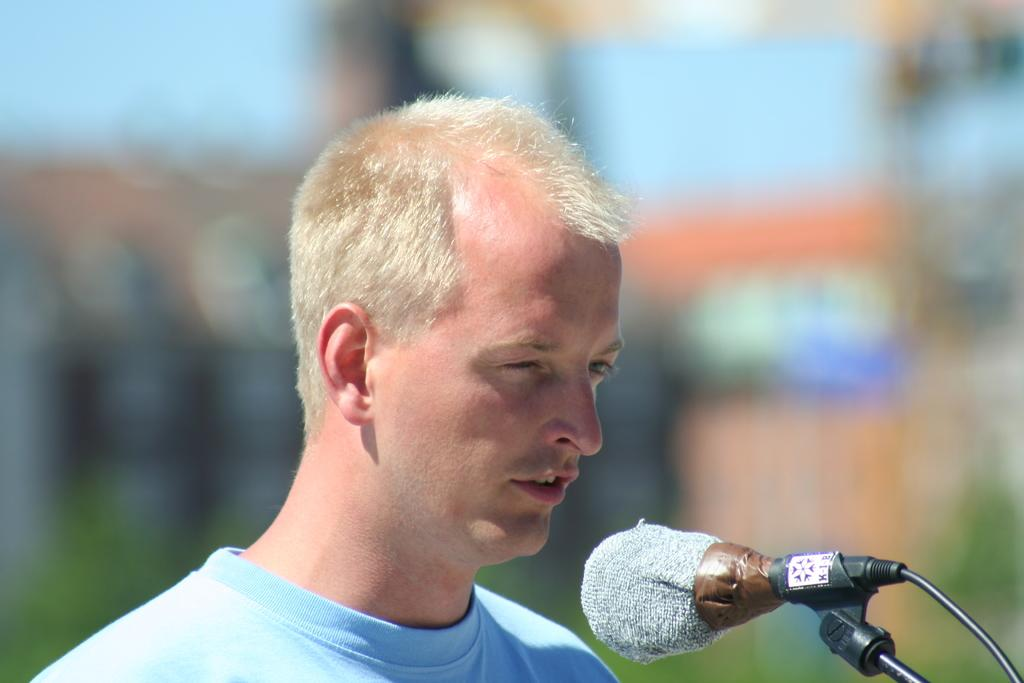Who or what is the main subject of the image? There is a person in the image. What object is in front of the person? There is a microphone in front of the person. Can you describe the background of the image? The background of the image is blurred. What type of engine can be seen in the background of the image? There is no engine present in the image; the background is blurred. What story is the person telling into the microphone in the image? The image does not provide any information about the person's story or what they might be saying into the microphone. 